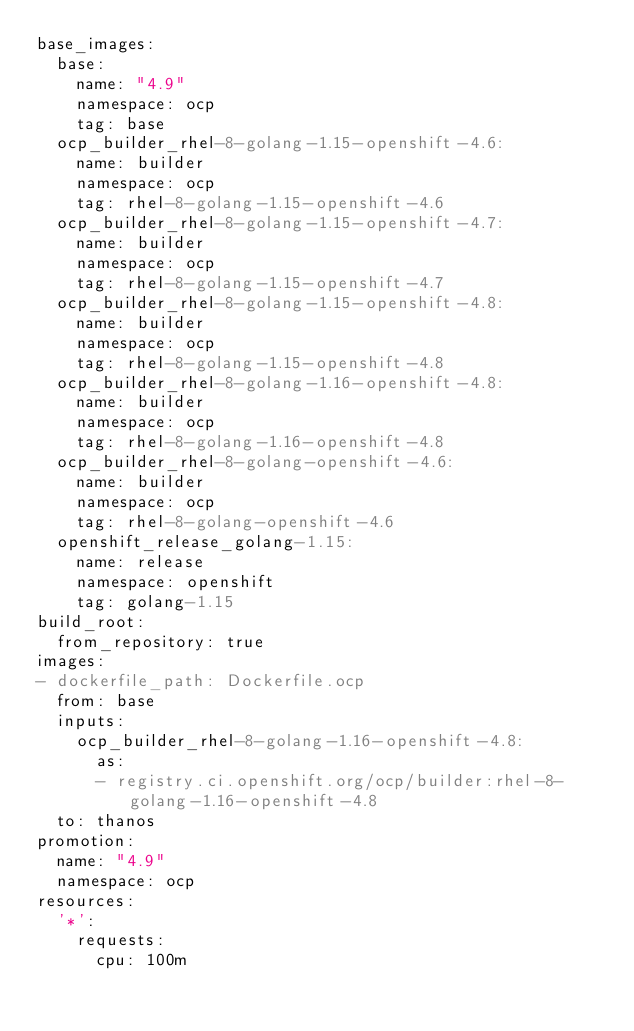<code> <loc_0><loc_0><loc_500><loc_500><_YAML_>base_images:
  base:
    name: "4.9"
    namespace: ocp
    tag: base
  ocp_builder_rhel-8-golang-1.15-openshift-4.6:
    name: builder
    namespace: ocp
    tag: rhel-8-golang-1.15-openshift-4.6
  ocp_builder_rhel-8-golang-1.15-openshift-4.7:
    name: builder
    namespace: ocp
    tag: rhel-8-golang-1.15-openshift-4.7
  ocp_builder_rhel-8-golang-1.15-openshift-4.8:
    name: builder
    namespace: ocp
    tag: rhel-8-golang-1.15-openshift-4.8
  ocp_builder_rhel-8-golang-1.16-openshift-4.8:
    name: builder
    namespace: ocp
    tag: rhel-8-golang-1.16-openshift-4.8
  ocp_builder_rhel-8-golang-openshift-4.6:
    name: builder
    namespace: ocp
    tag: rhel-8-golang-openshift-4.6
  openshift_release_golang-1.15:
    name: release
    namespace: openshift
    tag: golang-1.15
build_root:
  from_repository: true
images:
- dockerfile_path: Dockerfile.ocp
  from: base
  inputs:
    ocp_builder_rhel-8-golang-1.16-openshift-4.8:
      as:
      - registry.ci.openshift.org/ocp/builder:rhel-8-golang-1.16-openshift-4.8
  to: thanos
promotion:
  name: "4.9"
  namespace: ocp
resources:
  '*':
    requests:
      cpu: 100m</code> 